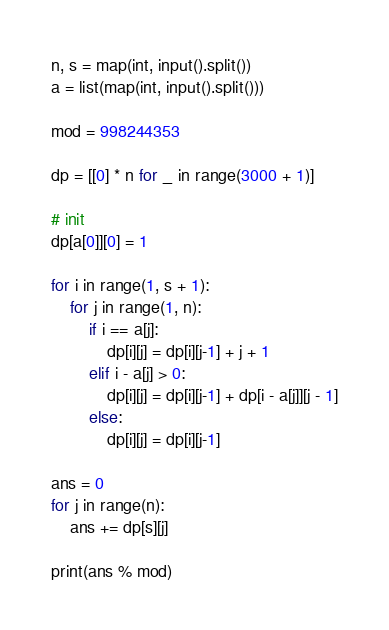<code> <loc_0><loc_0><loc_500><loc_500><_Python_>n, s = map(int, input().split())
a = list(map(int, input().split()))

mod = 998244353

dp = [[0] * n for _ in range(3000 + 1)]

# init
dp[a[0]][0] = 1

for i in range(1, s + 1):
    for j in range(1, n):
        if i == a[j]:
            dp[i][j] = dp[i][j-1] + j + 1
        elif i - a[j] > 0:
            dp[i][j] = dp[i][j-1] + dp[i - a[j]][j - 1]
        else:
            dp[i][j] = dp[i][j-1]

ans = 0
for j in range(n):
    ans += dp[s][j]

print(ans % mod)
</code> 